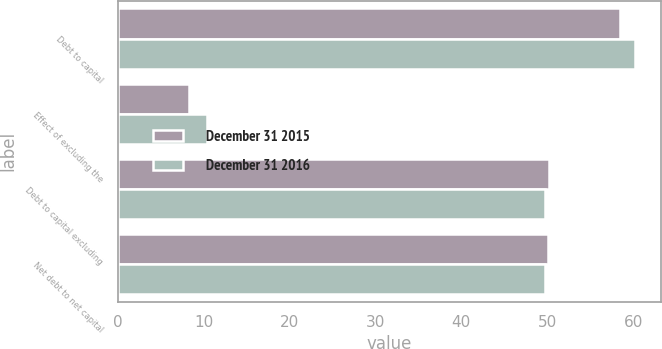<chart> <loc_0><loc_0><loc_500><loc_500><stacked_bar_chart><ecel><fcel>Debt to capital<fcel>Effect of excluding the<fcel>Debt to capital excluding<fcel>Net debt to net capital<nl><fcel>December 31 2015<fcel>58.5<fcel>8.3<fcel>50.2<fcel>50.1<nl><fcel>December 31 2016<fcel>60.2<fcel>10.4<fcel>49.8<fcel>49.8<nl></chart> 